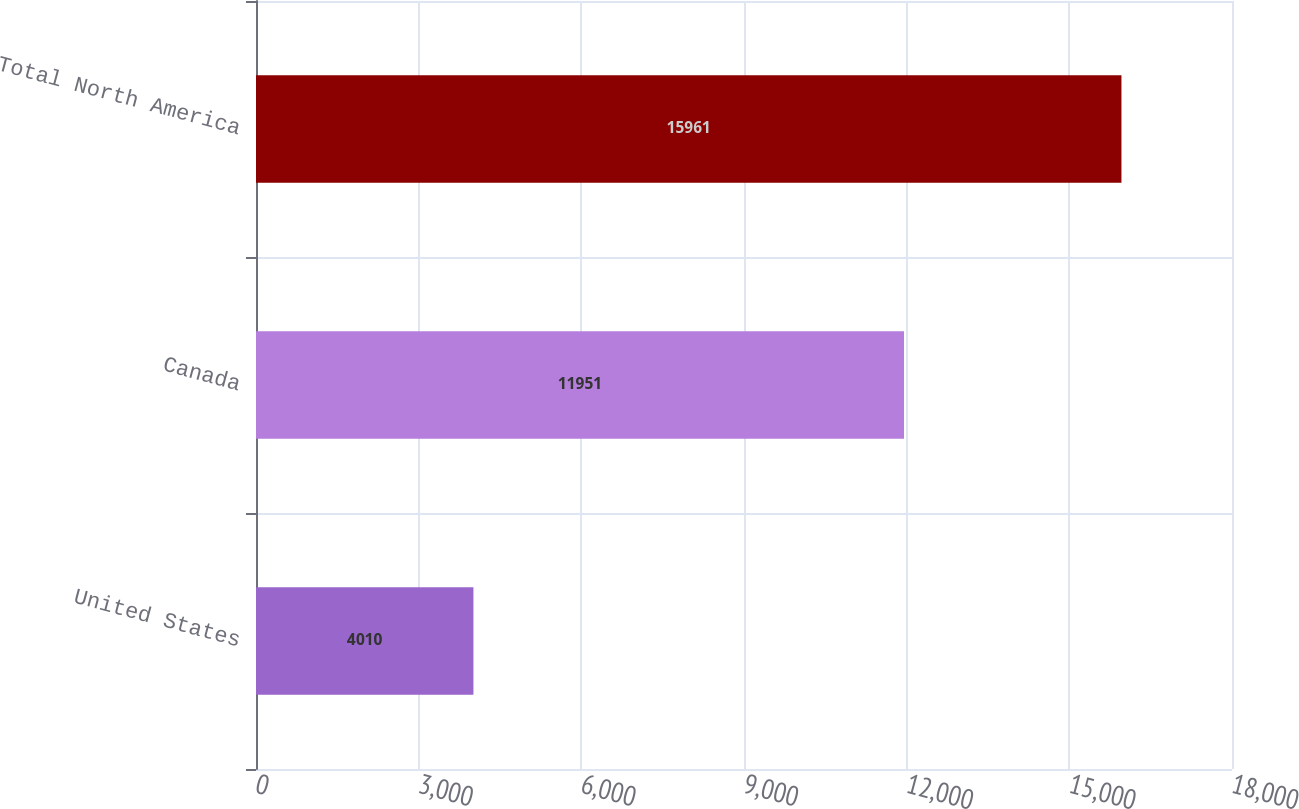Convert chart. <chart><loc_0><loc_0><loc_500><loc_500><bar_chart><fcel>United States<fcel>Canada<fcel>Total North America<nl><fcel>4010<fcel>11951<fcel>15961<nl></chart> 